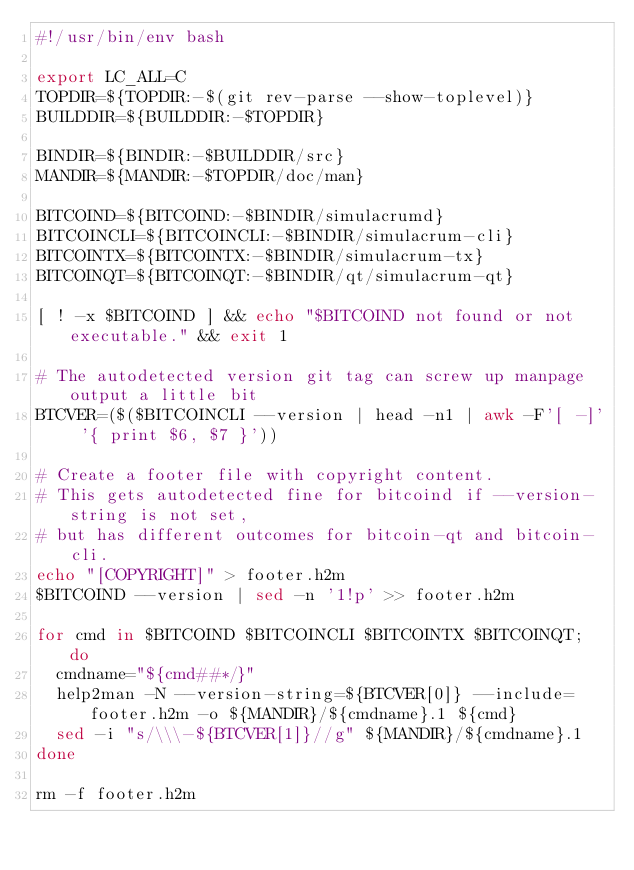Convert code to text. <code><loc_0><loc_0><loc_500><loc_500><_Bash_>#!/usr/bin/env bash

export LC_ALL=C
TOPDIR=${TOPDIR:-$(git rev-parse --show-toplevel)}
BUILDDIR=${BUILDDIR:-$TOPDIR}

BINDIR=${BINDIR:-$BUILDDIR/src}
MANDIR=${MANDIR:-$TOPDIR/doc/man}

BITCOIND=${BITCOIND:-$BINDIR/simulacrumd}
BITCOINCLI=${BITCOINCLI:-$BINDIR/simulacrum-cli}
BITCOINTX=${BITCOINTX:-$BINDIR/simulacrum-tx}
BITCOINQT=${BITCOINQT:-$BINDIR/qt/simulacrum-qt}

[ ! -x $BITCOIND ] && echo "$BITCOIND not found or not executable." && exit 1

# The autodetected version git tag can screw up manpage output a little bit
BTCVER=($($BITCOINCLI --version | head -n1 | awk -F'[ -]' '{ print $6, $7 }'))

# Create a footer file with copyright content.
# This gets autodetected fine for bitcoind if --version-string is not set,
# but has different outcomes for bitcoin-qt and bitcoin-cli.
echo "[COPYRIGHT]" > footer.h2m
$BITCOIND --version | sed -n '1!p' >> footer.h2m

for cmd in $BITCOIND $BITCOINCLI $BITCOINTX $BITCOINQT; do
  cmdname="${cmd##*/}"
  help2man -N --version-string=${BTCVER[0]} --include=footer.h2m -o ${MANDIR}/${cmdname}.1 ${cmd}
  sed -i "s/\\\-${BTCVER[1]}//g" ${MANDIR}/${cmdname}.1
done

rm -f footer.h2m
</code> 